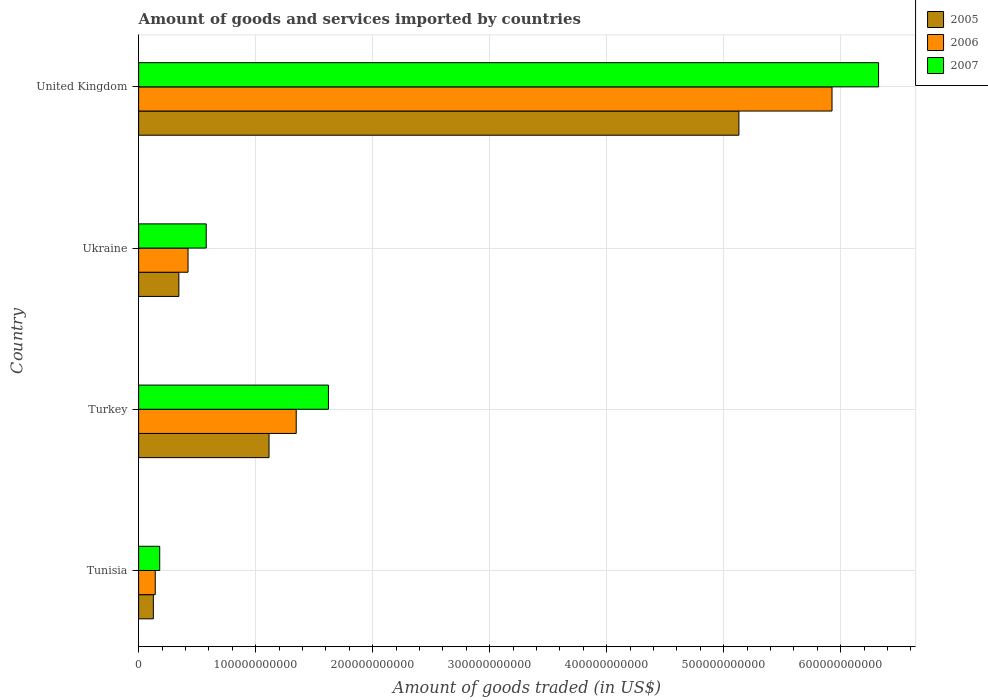Are the number of bars on each tick of the Y-axis equal?
Ensure brevity in your answer.  Yes. How many bars are there on the 1st tick from the top?
Provide a short and direct response. 3. What is the label of the 2nd group of bars from the top?
Your response must be concise. Ukraine. What is the total amount of goods and services imported in 2006 in Ukraine?
Ensure brevity in your answer.  4.22e+1. Across all countries, what is the maximum total amount of goods and services imported in 2007?
Offer a terse response. 6.32e+11. Across all countries, what is the minimum total amount of goods and services imported in 2005?
Your answer should be compact. 1.26e+1. In which country was the total amount of goods and services imported in 2006 maximum?
Offer a terse response. United Kingdom. In which country was the total amount of goods and services imported in 2007 minimum?
Make the answer very short. Tunisia. What is the total total amount of goods and services imported in 2006 in the graph?
Your answer should be very brief. 7.84e+11. What is the difference between the total amount of goods and services imported in 2006 in Tunisia and that in Turkey?
Your response must be concise. -1.20e+11. What is the difference between the total amount of goods and services imported in 2007 in Ukraine and the total amount of goods and services imported in 2006 in Turkey?
Make the answer very short. -7.69e+1. What is the average total amount of goods and services imported in 2006 per country?
Offer a terse response. 1.96e+11. What is the difference between the total amount of goods and services imported in 2006 and total amount of goods and services imported in 2005 in Ukraine?
Your answer should be compact. 7.84e+09. What is the ratio of the total amount of goods and services imported in 2005 in Tunisia to that in Ukraine?
Give a very brief answer. 0.37. Is the total amount of goods and services imported in 2006 in Turkey less than that in United Kingdom?
Provide a short and direct response. Yes. Is the difference between the total amount of goods and services imported in 2006 in Tunisia and Turkey greater than the difference between the total amount of goods and services imported in 2005 in Tunisia and Turkey?
Provide a succinct answer. No. What is the difference between the highest and the second highest total amount of goods and services imported in 2006?
Your answer should be compact. 4.58e+11. What is the difference between the highest and the lowest total amount of goods and services imported in 2006?
Provide a succinct answer. 5.78e+11. In how many countries, is the total amount of goods and services imported in 2006 greater than the average total amount of goods and services imported in 2006 taken over all countries?
Your answer should be compact. 1. Is the sum of the total amount of goods and services imported in 2005 in Tunisia and Turkey greater than the maximum total amount of goods and services imported in 2007 across all countries?
Offer a very short reply. No. What does the 1st bar from the bottom in Turkey represents?
Provide a short and direct response. 2005. Are all the bars in the graph horizontal?
Offer a terse response. Yes. How many countries are there in the graph?
Provide a short and direct response. 4. What is the difference between two consecutive major ticks on the X-axis?
Your answer should be very brief. 1.00e+11. Are the values on the major ticks of X-axis written in scientific E-notation?
Your response must be concise. No. Does the graph contain any zero values?
Give a very brief answer. No. Does the graph contain grids?
Ensure brevity in your answer.  Yes. What is the title of the graph?
Your response must be concise. Amount of goods and services imported by countries. What is the label or title of the X-axis?
Make the answer very short. Amount of goods traded (in US$). What is the Amount of goods traded (in US$) in 2005 in Tunisia?
Offer a terse response. 1.26e+1. What is the Amount of goods traded (in US$) of 2006 in Tunisia?
Your answer should be very brief. 1.42e+1. What is the Amount of goods traded (in US$) in 2007 in Tunisia?
Keep it short and to the point. 1.80e+1. What is the Amount of goods traded (in US$) of 2005 in Turkey?
Give a very brief answer. 1.11e+11. What is the Amount of goods traded (in US$) in 2006 in Turkey?
Make the answer very short. 1.35e+11. What is the Amount of goods traded (in US$) in 2007 in Turkey?
Ensure brevity in your answer.  1.62e+11. What is the Amount of goods traded (in US$) in 2005 in Ukraine?
Offer a terse response. 3.44e+1. What is the Amount of goods traded (in US$) of 2006 in Ukraine?
Offer a very short reply. 4.22e+1. What is the Amount of goods traded (in US$) in 2007 in Ukraine?
Make the answer very short. 5.78e+1. What is the Amount of goods traded (in US$) of 2005 in United Kingdom?
Keep it short and to the point. 5.13e+11. What is the Amount of goods traded (in US$) of 2006 in United Kingdom?
Keep it short and to the point. 5.93e+11. What is the Amount of goods traded (in US$) in 2007 in United Kingdom?
Offer a terse response. 6.32e+11. Across all countries, what is the maximum Amount of goods traded (in US$) of 2005?
Your response must be concise. 5.13e+11. Across all countries, what is the maximum Amount of goods traded (in US$) of 2006?
Your response must be concise. 5.93e+11. Across all countries, what is the maximum Amount of goods traded (in US$) of 2007?
Make the answer very short. 6.32e+11. Across all countries, what is the minimum Amount of goods traded (in US$) in 2005?
Offer a very short reply. 1.26e+1. Across all countries, what is the minimum Amount of goods traded (in US$) in 2006?
Your response must be concise. 1.42e+1. Across all countries, what is the minimum Amount of goods traded (in US$) of 2007?
Provide a succinct answer. 1.80e+1. What is the total Amount of goods traded (in US$) in 2005 in the graph?
Your answer should be very brief. 6.71e+11. What is the total Amount of goods traded (in US$) of 2006 in the graph?
Your answer should be compact. 7.84e+11. What is the total Amount of goods traded (in US$) in 2007 in the graph?
Keep it short and to the point. 8.70e+11. What is the difference between the Amount of goods traded (in US$) of 2005 in Tunisia and that in Turkey?
Offer a very short reply. -9.89e+1. What is the difference between the Amount of goods traded (in US$) of 2006 in Tunisia and that in Turkey?
Your answer should be very brief. -1.20e+11. What is the difference between the Amount of goods traded (in US$) in 2007 in Tunisia and that in Turkey?
Offer a terse response. -1.44e+11. What is the difference between the Amount of goods traded (in US$) of 2005 in Tunisia and that in Ukraine?
Provide a short and direct response. -2.18e+1. What is the difference between the Amount of goods traded (in US$) of 2006 in Tunisia and that in Ukraine?
Keep it short and to the point. -2.80e+1. What is the difference between the Amount of goods traded (in US$) of 2007 in Tunisia and that in Ukraine?
Your answer should be very brief. -3.97e+1. What is the difference between the Amount of goods traded (in US$) in 2005 in Tunisia and that in United Kingdom?
Give a very brief answer. -5.00e+11. What is the difference between the Amount of goods traded (in US$) of 2006 in Tunisia and that in United Kingdom?
Ensure brevity in your answer.  -5.78e+11. What is the difference between the Amount of goods traded (in US$) of 2007 in Tunisia and that in United Kingdom?
Your response must be concise. -6.14e+11. What is the difference between the Amount of goods traded (in US$) of 2005 in Turkey and that in Ukraine?
Keep it short and to the point. 7.71e+1. What is the difference between the Amount of goods traded (in US$) in 2006 in Turkey and that in Ukraine?
Offer a terse response. 9.25e+1. What is the difference between the Amount of goods traded (in US$) in 2007 in Turkey and that in Ukraine?
Your answer should be compact. 1.04e+11. What is the difference between the Amount of goods traded (in US$) of 2005 in Turkey and that in United Kingdom?
Make the answer very short. -4.02e+11. What is the difference between the Amount of goods traded (in US$) of 2006 in Turkey and that in United Kingdom?
Make the answer very short. -4.58e+11. What is the difference between the Amount of goods traded (in US$) of 2007 in Turkey and that in United Kingdom?
Your answer should be compact. -4.70e+11. What is the difference between the Amount of goods traded (in US$) in 2005 in Ukraine and that in United Kingdom?
Your response must be concise. -4.79e+11. What is the difference between the Amount of goods traded (in US$) of 2006 in Ukraine and that in United Kingdom?
Provide a short and direct response. -5.50e+11. What is the difference between the Amount of goods traded (in US$) in 2007 in Ukraine and that in United Kingdom?
Your answer should be very brief. -5.75e+11. What is the difference between the Amount of goods traded (in US$) of 2005 in Tunisia and the Amount of goods traded (in US$) of 2006 in Turkey?
Your response must be concise. -1.22e+11. What is the difference between the Amount of goods traded (in US$) in 2005 in Tunisia and the Amount of goods traded (in US$) in 2007 in Turkey?
Your response must be concise. -1.50e+11. What is the difference between the Amount of goods traded (in US$) of 2006 in Tunisia and the Amount of goods traded (in US$) of 2007 in Turkey?
Make the answer very short. -1.48e+11. What is the difference between the Amount of goods traded (in US$) of 2005 in Tunisia and the Amount of goods traded (in US$) of 2006 in Ukraine?
Offer a terse response. -2.96e+1. What is the difference between the Amount of goods traded (in US$) in 2005 in Tunisia and the Amount of goods traded (in US$) in 2007 in Ukraine?
Your response must be concise. -4.52e+1. What is the difference between the Amount of goods traded (in US$) of 2006 in Tunisia and the Amount of goods traded (in US$) of 2007 in Ukraine?
Ensure brevity in your answer.  -4.36e+1. What is the difference between the Amount of goods traded (in US$) of 2005 in Tunisia and the Amount of goods traded (in US$) of 2006 in United Kingdom?
Offer a terse response. -5.80e+11. What is the difference between the Amount of goods traded (in US$) in 2005 in Tunisia and the Amount of goods traded (in US$) in 2007 in United Kingdom?
Offer a very short reply. -6.20e+11. What is the difference between the Amount of goods traded (in US$) of 2006 in Tunisia and the Amount of goods traded (in US$) of 2007 in United Kingdom?
Your answer should be very brief. -6.18e+11. What is the difference between the Amount of goods traded (in US$) of 2005 in Turkey and the Amount of goods traded (in US$) of 2006 in Ukraine?
Provide a succinct answer. 6.92e+1. What is the difference between the Amount of goods traded (in US$) of 2005 in Turkey and the Amount of goods traded (in US$) of 2007 in Ukraine?
Offer a very short reply. 5.37e+1. What is the difference between the Amount of goods traded (in US$) in 2006 in Turkey and the Amount of goods traded (in US$) in 2007 in Ukraine?
Ensure brevity in your answer.  7.69e+1. What is the difference between the Amount of goods traded (in US$) of 2005 in Turkey and the Amount of goods traded (in US$) of 2006 in United Kingdom?
Keep it short and to the point. -4.81e+11. What is the difference between the Amount of goods traded (in US$) of 2005 in Turkey and the Amount of goods traded (in US$) of 2007 in United Kingdom?
Offer a terse response. -5.21e+11. What is the difference between the Amount of goods traded (in US$) in 2006 in Turkey and the Amount of goods traded (in US$) in 2007 in United Kingdom?
Keep it short and to the point. -4.98e+11. What is the difference between the Amount of goods traded (in US$) of 2005 in Ukraine and the Amount of goods traded (in US$) of 2006 in United Kingdom?
Offer a very short reply. -5.58e+11. What is the difference between the Amount of goods traded (in US$) in 2005 in Ukraine and the Amount of goods traded (in US$) in 2007 in United Kingdom?
Provide a short and direct response. -5.98e+11. What is the difference between the Amount of goods traded (in US$) of 2006 in Ukraine and the Amount of goods traded (in US$) of 2007 in United Kingdom?
Your answer should be compact. -5.90e+11. What is the average Amount of goods traded (in US$) of 2005 per country?
Your answer should be compact. 1.68e+11. What is the average Amount of goods traded (in US$) in 2006 per country?
Keep it short and to the point. 1.96e+11. What is the average Amount of goods traded (in US$) in 2007 per country?
Offer a very short reply. 2.18e+11. What is the difference between the Amount of goods traded (in US$) in 2005 and Amount of goods traded (in US$) in 2006 in Tunisia?
Your response must be concise. -1.61e+09. What is the difference between the Amount of goods traded (in US$) of 2005 and Amount of goods traded (in US$) of 2007 in Tunisia?
Ensure brevity in your answer.  -5.43e+09. What is the difference between the Amount of goods traded (in US$) of 2006 and Amount of goods traded (in US$) of 2007 in Tunisia?
Give a very brief answer. -3.82e+09. What is the difference between the Amount of goods traded (in US$) of 2005 and Amount of goods traded (in US$) of 2006 in Turkey?
Offer a terse response. -2.32e+1. What is the difference between the Amount of goods traded (in US$) of 2005 and Amount of goods traded (in US$) of 2007 in Turkey?
Your answer should be compact. -5.08e+1. What is the difference between the Amount of goods traded (in US$) of 2006 and Amount of goods traded (in US$) of 2007 in Turkey?
Give a very brief answer. -2.75e+1. What is the difference between the Amount of goods traded (in US$) of 2005 and Amount of goods traded (in US$) of 2006 in Ukraine?
Your answer should be very brief. -7.84e+09. What is the difference between the Amount of goods traded (in US$) in 2005 and Amount of goods traded (in US$) in 2007 in Ukraine?
Your answer should be compact. -2.34e+1. What is the difference between the Amount of goods traded (in US$) of 2006 and Amount of goods traded (in US$) of 2007 in Ukraine?
Your answer should be compact. -1.55e+1. What is the difference between the Amount of goods traded (in US$) of 2005 and Amount of goods traded (in US$) of 2006 in United Kingdom?
Offer a very short reply. -7.96e+1. What is the difference between the Amount of goods traded (in US$) of 2005 and Amount of goods traded (in US$) of 2007 in United Kingdom?
Ensure brevity in your answer.  -1.19e+11. What is the difference between the Amount of goods traded (in US$) in 2006 and Amount of goods traded (in US$) in 2007 in United Kingdom?
Your answer should be very brief. -3.98e+1. What is the ratio of the Amount of goods traded (in US$) of 2005 in Tunisia to that in Turkey?
Provide a succinct answer. 0.11. What is the ratio of the Amount of goods traded (in US$) in 2006 in Tunisia to that in Turkey?
Offer a very short reply. 0.11. What is the ratio of the Amount of goods traded (in US$) in 2005 in Tunisia to that in Ukraine?
Give a very brief answer. 0.37. What is the ratio of the Amount of goods traded (in US$) of 2006 in Tunisia to that in Ukraine?
Make the answer very short. 0.34. What is the ratio of the Amount of goods traded (in US$) of 2007 in Tunisia to that in Ukraine?
Ensure brevity in your answer.  0.31. What is the ratio of the Amount of goods traded (in US$) in 2005 in Tunisia to that in United Kingdom?
Keep it short and to the point. 0.02. What is the ratio of the Amount of goods traded (in US$) in 2006 in Tunisia to that in United Kingdom?
Your answer should be compact. 0.02. What is the ratio of the Amount of goods traded (in US$) in 2007 in Tunisia to that in United Kingdom?
Your response must be concise. 0.03. What is the ratio of the Amount of goods traded (in US$) in 2005 in Turkey to that in Ukraine?
Offer a terse response. 3.24. What is the ratio of the Amount of goods traded (in US$) of 2006 in Turkey to that in Ukraine?
Your answer should be compact. 3.19. What is the ratio of the Amount of goods traded (in US$) in 2007 in Turkey to that in Ukraine?
Provide a short and direct response. 2.81. What is the ratio of the Amount of goods traded (in US$) of 2005 in Turkey to that in United Kingdom?
Give a very brief answer. 0.22. What is the ratio of the Amount of goods traded (in US$) in 2006 in Turkey to that in United Kingdom?
Make the answer very short. 0.23. What is the ratio of the Amount of goods traded (in US$) of 2007 in Turkey to that in United Kingdom?
Offer a very short reply. 0.26. What is the ratio of the Amount of goods traded (in US$) in 2005 in Ukraine to that in United Kingdom?
Your answer should be very brief. 0.07. What is the ratio of the Amount of goods traded (in US$) in 2006 in Ukraine to that in United Kingdom?
Offer a terse response. 0.07. What is the ratio of the Amount of goods traded (in US$) of 2007 in Ukraine to that in United Kingdom?
Make the answer very short. 0.09. What is the difference between the highest and the second highest Amount of goods traded (in US$) of 2005?
Your response must be concise. 4.02e+11. What is the difference between the highest and the second highest Amount of goods traded (in US$) of 2006?
Your answer should be very brief. 4.58e+11. What is the difference between the highest and the second highest Amount of goods traded (in US$) in 2007?
Your answer should be very brief. 4.70e+11. What is the difference between the highest and the lowest Amount of goods traded (in US$) of 2005?
Make the answer very short. 5.00e+11. What is the difference between the highest and the lowest Amount of goods traded (in US$) of 2006?
Make the answer very short. 5.78e+11. What is the difference between the highest and the lowest Amount of goods traded (in US$) in 2007?
Give a very brief answer. 6.14e+11. 